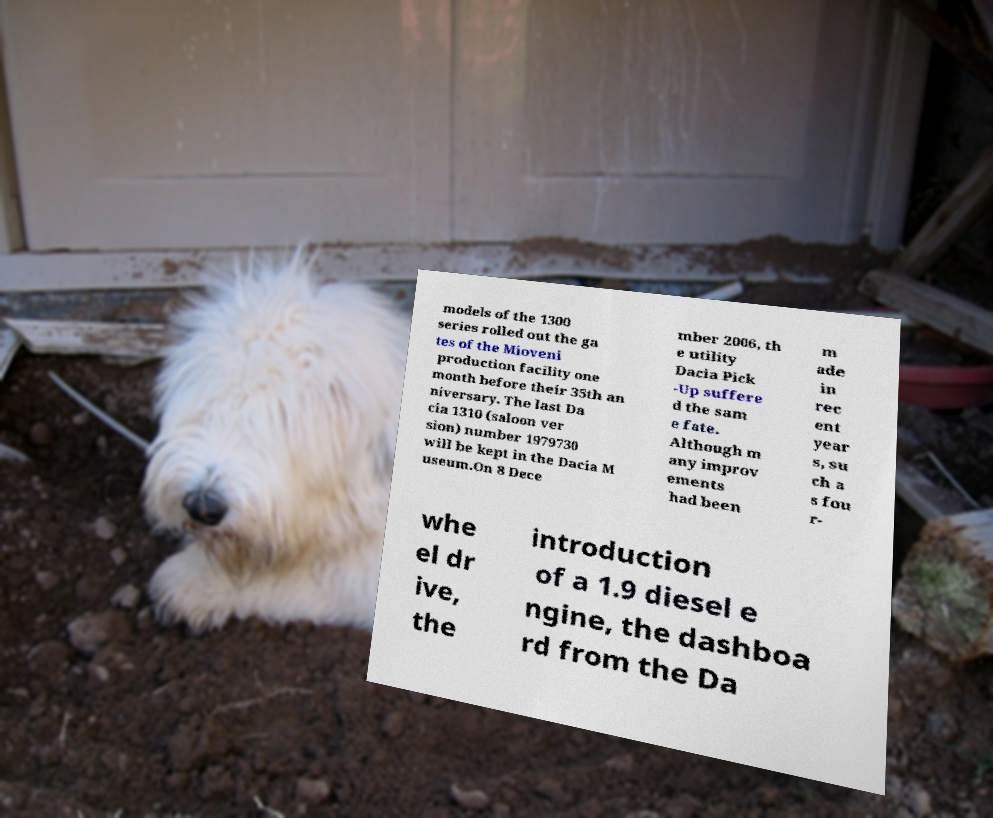Can you read and provide the text displayed in the image?This photo seems to have some interesting text. Can you extract and type it out for me? models of the 1300 series rolled out the ga tes of the Mioveni production facility one month before their 35th an niversary. The last Da cia 1310 (saloon ver sion) number 1979730 will be kept in the Dacia M useum.On 8 Dece mber 2006, th e utility Dacia Pick -Up suffere d the sam e fate. Although m any improv ements had been m ade in rec ent year s, su ch a s fou r- whe el dr ive, the introduction of a 1.9 diesel e ngine, the dashboa rd from the Da 